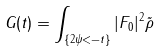<formula> <loc_0><loc_0><loc_500><loc_500>G ( t ) = \int _ { \{ 2 \psi < - t \} } | F _ { 0 } | ^ { 2 } \tilde { \rho }</formula> 